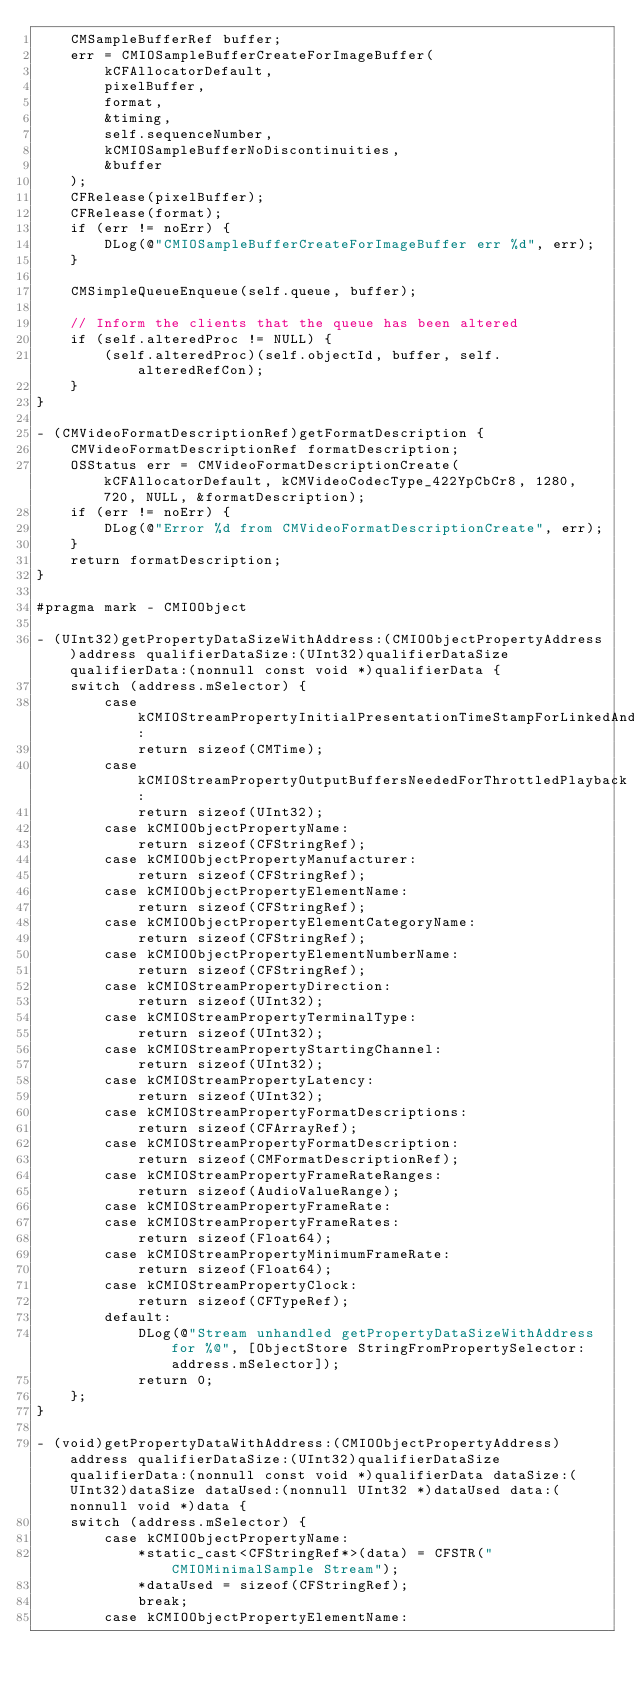Convert code to text. <code><loc_0><loc_0><loc_500><loc_500><_ObjectiveC_>    CMSampleBufferRef buffer;
    err = CMIOSampleBufferCreateForImageBuffer(
        kCFAllocatorDefault,
        pixelBuffer,
        format,
        &timing,
        self.sequenceNumber,
        kCMIOSampleBufferNoDiscontinuities,
        &buffer
    );
    CFRelease(pixelBuffer);
    CFRelease(format);
    if (err != noErr) {
        DLog(@"CMIOSampleBufferCreateForImageBuffer err %d", err);
    }

    CMSimpleQueueEnqueue(self.queue, buffer);

    // Inform the clients that the queue has been altered
    if (self.alteredProc != NULL) {
        (self.alteredProc)(self.objectId, buffer, self.alteredRefCon);
    }
}

- (CMVideoFormatDescriptionRef)getFormatDescription {
    CMVideoFormatDescriptionRef formatDescription;
    OSStatus err = CMVideoFormatDescriptionCreate(kCFAllocatorDefault, kCMVideoCodecType_422YpCbCr8, 1280, 720, NULL, &formatDescription);
    if (err != noErr) {
        DLog(@"Error %d from CMVideoFormatDescriptionCreate", err);
    }
    return formatDescription;
}

#pragma mark - CMIOObject

- (UInt32)getPropertyDataSizeWithAddress:(CMIOObjectPropertyAddress)address qualifierDataSize:(UInt32)qualifierDataSize qualifierData:(nonnull const void *)qualifierData {
    switch (address.mSelector) {
        case kCMIOStreamPropertyInitialPresentationTimeStampForLinkedAndSyncedAudio:
            return sizeof(CMTime);
        case kCMIOStreamPropertyOutputBuffersNeededForThrottledPlayback:
            return sizeof(UInt32);
        case kCMIOObjectPropertyName:
            return sizeof(CFStringRef);
        case kCMIOObjectPropertyManufacturer:
            return sizeof(CFStringRef);
        case kCMIOObjectPropertyElementName:
            return sizeof(CFStringRef);
        case kCMIOObjectPropertyElementCategoryName:
            return sizeof(CFStringRef);
        case kCMIOObjectPropertyElementNumberName:
            return sizeof(CFStringRef);
        case kCMIOStreamPropertyDirection:
            return sizeof(UInt32);
        case kCMIOStreamPropertyTerminalType:
            return sizeof(UInt32);
        case kCMIOStreamPropertyStartingChannel:
            return sizeof(UInt32);
        case kCMIOStreamPropertyLatency:
            return sizeof(UInt32);
        case kCMIOStreamPropertyFormatDescriptions:
            return sizeof(CFArrayRef);
        case kCMIOStreamPropertyFormatDescription:
            return sizeof(CMFormatDescriptionRef);
        case kCMIOStreamPropertyFrameRateRanges:
            return sizeof(AudioValueRange);
        case kCMIOStreamPropertyFrameRate:
        case kCMIOStreamPropertyFrameRates:
            return sizeof(Float64);
        case kCMIOStreamPropertyMinimumFrameRate:
            return sizeof(Float64);
        case kCMIOStreamPropertyClock:
            return sizeof(CFTypeRef);
        default:
            DLog(@"Stream unhandled getPropertyDataSizeWithAddress for %@", [ObjectStore StringFromPropertySelector:address.mSelector]);
            return 0;
    };
}

- (void)getPropertyDataWithAddress:(CMIOObjectPropertyAddress)address qualifierDataSize:(UInt32)qualifierDataSize qualifierData:(nonnull const void *)qualifierData dataSize:(UInt32)dataSize dataUsed:(nonnull UInt32 *)dataUsed data:(nonnull void *)data {
    switch (address.mSelector) {
        case kCMIOObjectPropertyName:
            *static_cast<CFStringRef*>(data) = CFSTR("CMIOMinimalSample Stream");
            *dataUsed = sizeof(CFStringRef);
            break;
        case kCMIOObjectPropertyElementName:</code> 